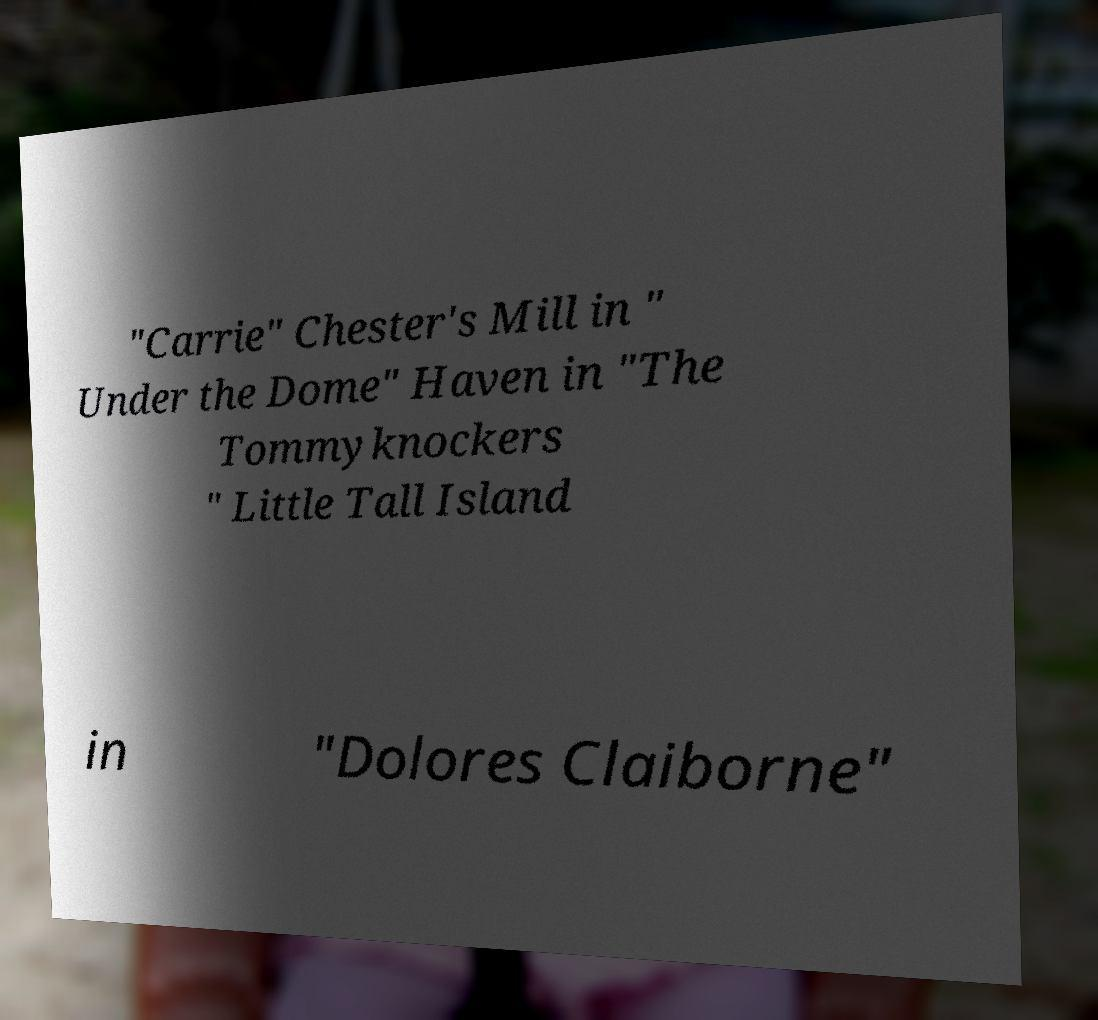Can you accurately transcribe the text from the provided image for me? "Carrie" Chester's Mill in " Under the Dome" Haven in "The Tommyknockers " Little Tall Island in "Dolores Claiborne" 